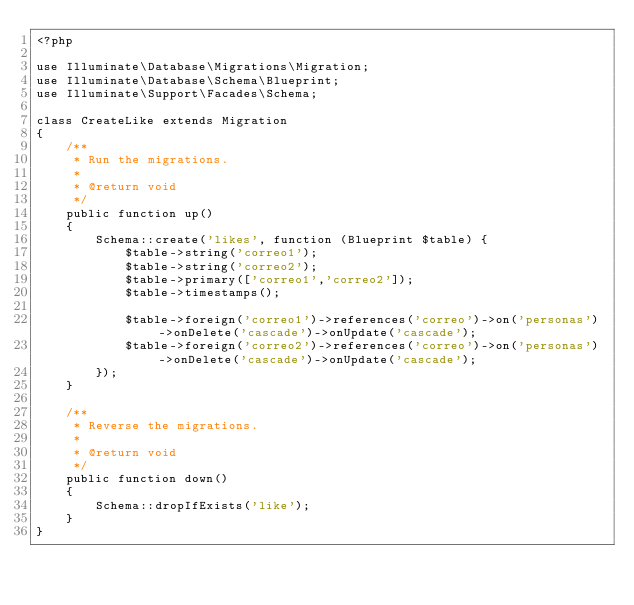<code> <loc_0><loc_0><loc_500><loc_500><_PHP_><?php

use Illuminate\Database\Migrations\Migration;
use Illuminate\Database\Schema\Blueprint;
use Illuminate\Support\Facades\Schema;

class CreateLike extends Migration
{
    /**
     * Run the migrations.
     *
     * @return void
     */
    public function up()
    {
        Schema::create('likes', function (Blueprint $table) {
            $table->string('correo1');
            $table->string('correo2');
            $table->primary(['correo1','correo2']);
            $table->timestamps();

            $table->foreign('correo1')->references('correo')->on('personas')->onDelete('cascade')->onUpdate('cascade');
            $table->foreign('correo2')->references('correo')->on('personas')->onDelete('cascade')->onUpdate('cascade');
        });
    }

    /**
     * Reverse the migrations.
     *
     * @return void
     */
    public function down()
    {
        Schema::dropIfExists('like');
    }
}
</code> 